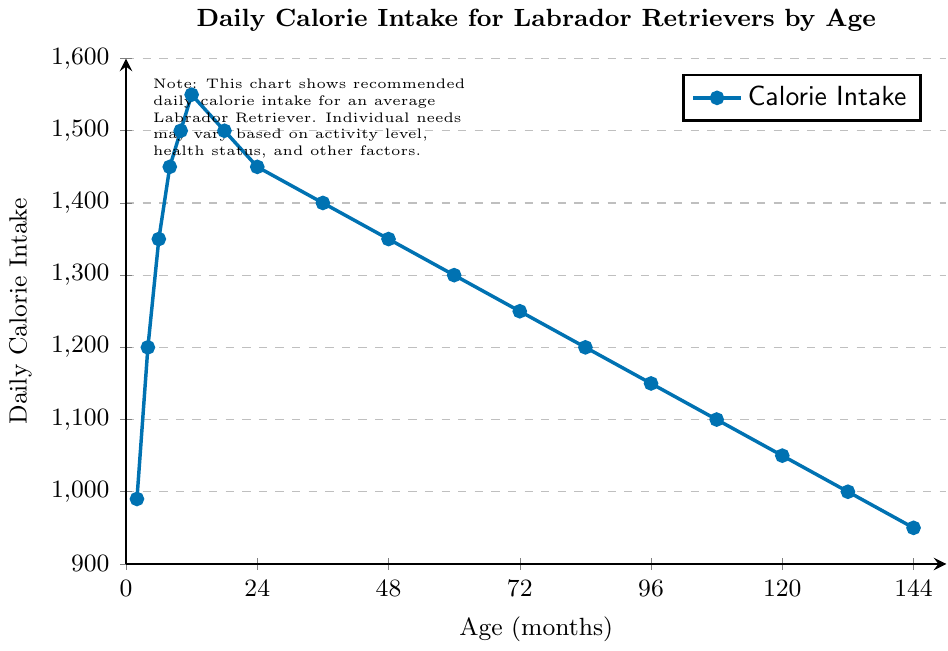What's the daily calorie intake recommendation for a Labrador Retriever at 12 months? Look at the point corresponding to 12 months on the x-axis and see the value on the y-axis.
Answer: 1550 At what age does the daily calorie intake for a Labrador Retriever peak, and what is the value? Check the graph for the highest point on the y-axis and note the corresponding x-axis value.
Answer: 12 months, 1550 calories How does the daily calorie intake change from 24 months to 36 months? Observe the y-axis values at 24 months (1450) and 36 months (1400) and calculate the difference.
Answer: It decreases by 50 calories What's the average daily calorie intake recommendation between 2 months and 12 months? Add the calorie values from 2 to 12 months (990 + 1200 + 1350 + 1450 + 1500 + 1550) and then divide by the number of points (6).
Answer: 1356.67 calories At what age do Labrador Retrievers require 1100 daily calories? Find the point on the graph where the y-axis value is 1100 and check the corresponding x-axis value.
Answer: 108 months Compare the daily calorie intake recommendations for a 4-month-old and a 96-month-old Labrador Retriever. Check the y-axis values for 4 months (1200) and 96 months (1150) and compare.
Answer: 4 months needs 50 more calories Which age group sees the most significant decrease in daily calorie intake, and what is that decrease? Identify two consecutive points with the largest y-axis difference. The largest change is between 12 months (1550) and 18 months (1500). Calculate the difference.
Answer: 12-18 months, 50 calories What is the total recommended calorie intake from age 2 months to 144 months? Sum the calorie values from 2 to 144 months.
Answer: 20490 calories Is there any age where the recommended daily calorie intake decreases and then increases again, and if so, where? Look for a section in the graph with a dip followed by a rise. No such points are evident; the intake steadily decreases.
Answer: No What is the downward trend in daily calorie intake from 60 months to 144 months? Identify the calorie values at 60 months (1300) and 144 months (950) and calculate the total decrease.
Answer: It decreases by 350 calories 